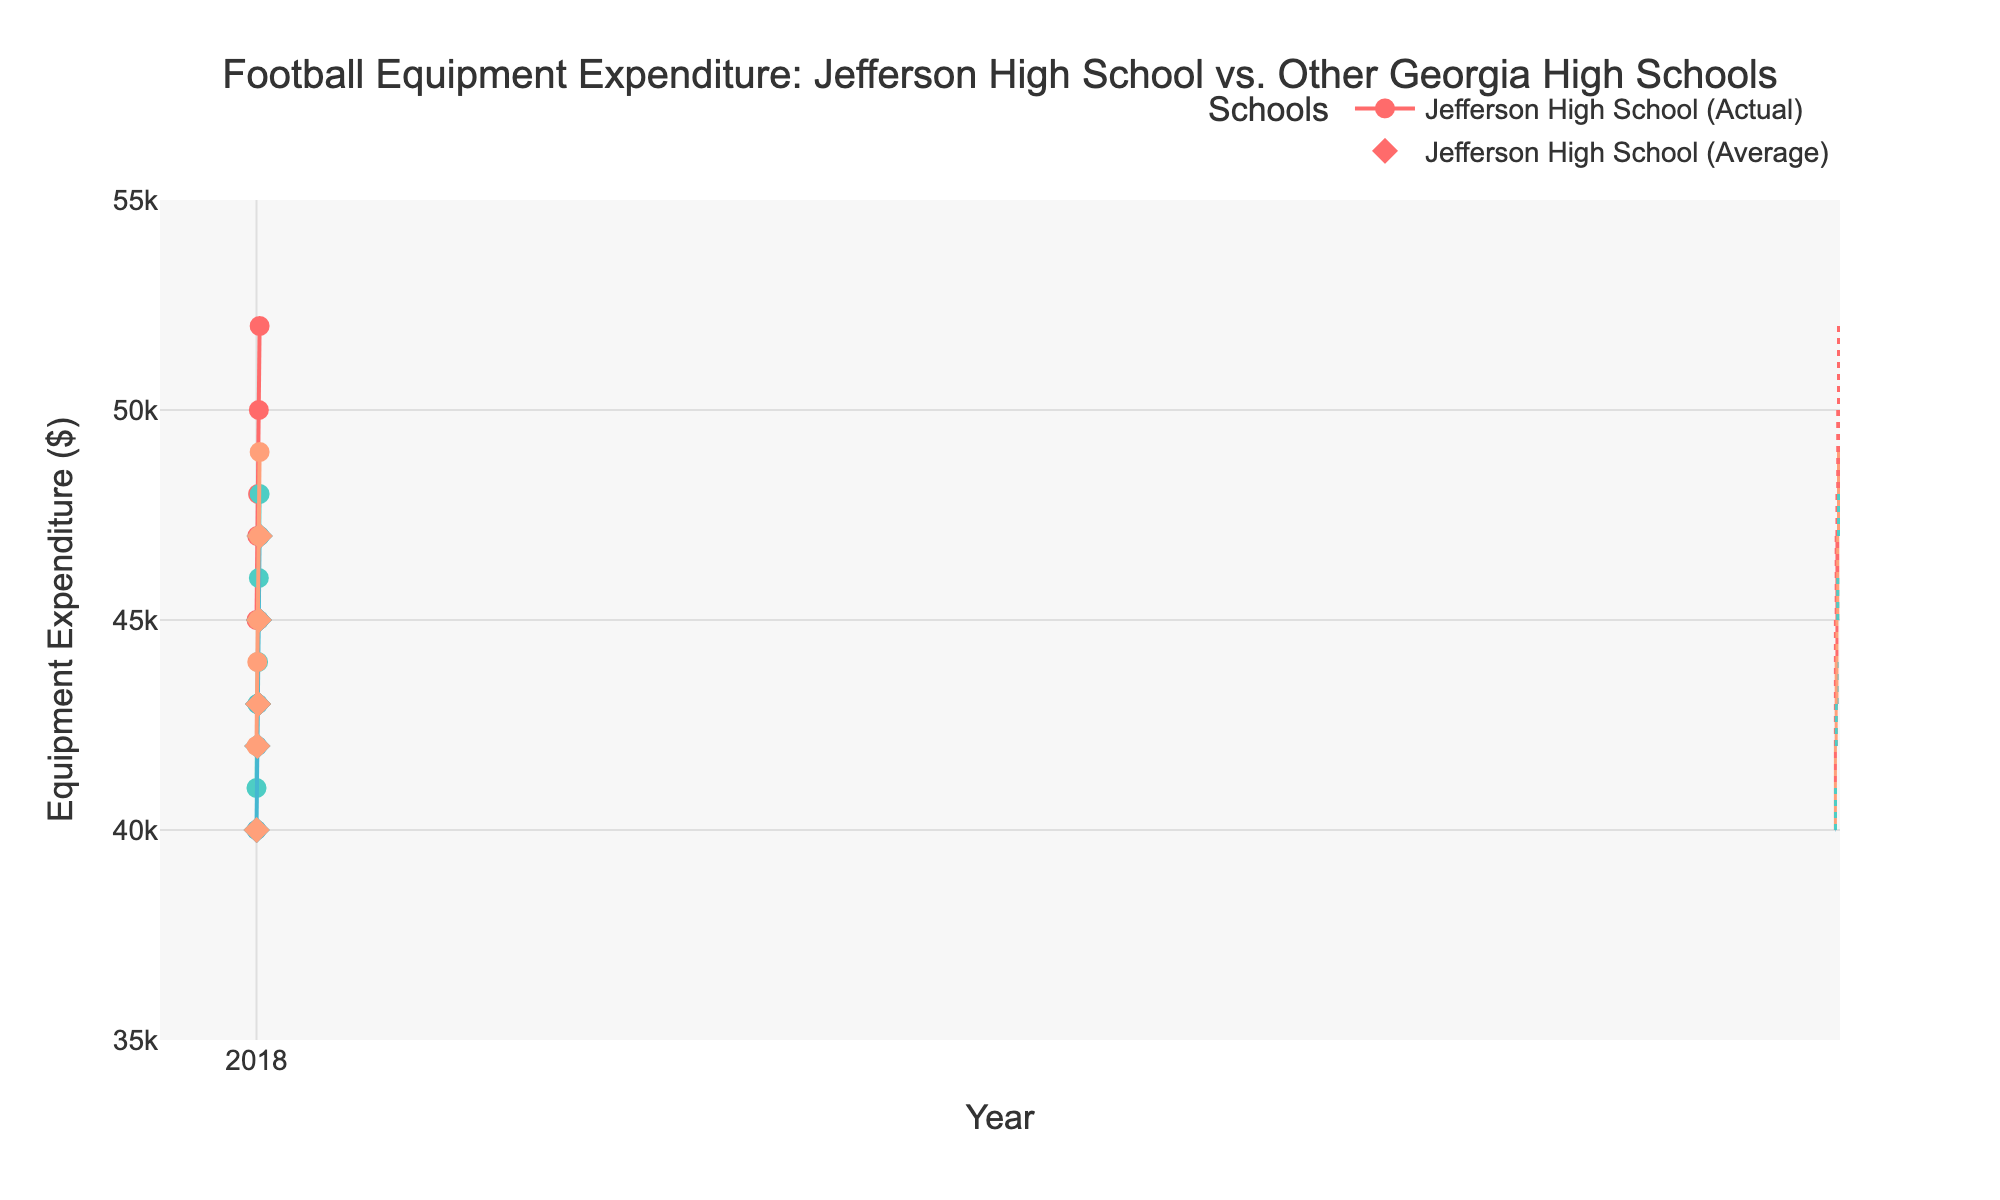what is the title of the plot? The title is located at the top of the plot and reads "Football Equipment Expenditure: Jefferson High School vs. Other Georgia High Schools."
Answer: Football Equipment Expenditure: Jefferson High School vs. Other Georgia High Schools What is the y-axis title? The y-axis title can be found on the side of the chart and reads "Equipment Expenditure ($)."
Answer: Equipment Expenditure ($) How many schools are compared in the plot? The plot compares four different schools, which can be identified by looking at the different lines and markers in the figure corresponding to each school.
Answer: Four What is the color associated with Jefferson High School? Jefferson High School's actual expenditure is marked with a specific color used for the line and circle markers, which is red.
Answer: Red How did Jefferson High School's expenditure trend relative to other schools' average in 2019? By observing the plot for the year 2019, you can see that Jefferson High School's marker is higher than the average indicated by the diamond marker.
Answer: Higher What was the range of Jefferson High School's expenditure from 2018 to 2022? To find the range, identify the highest and lowest expenditures of Jefferson High School from the figure. The highest is $52000 in 2022, and the lowest is $45000 in 2018. The range is $52000 - $45000.
Answer: $7000 How does the trend of Jefferson High School differ from Mill Creek High School over these years? By examining the plot, both schools show an increasing trend in expenditure. However, Jefferson High School's expenditures are consistently higher than those of Mill Creek High School.
Answer: Consistently higher What is the overall trend of football equipment expenditures for Jefferson High School from 2018 to 2022? By tracking Jefferson High School's expenditure line from 2018 to 2022, the overall trend is increasing.
Answer: Increasing What is the maximum difference in equipment expenditure between Jefferson High School and other high schools' average in a single year? To find the maximum difference, observe each year: the differences are $5000 (2018), $5000 (2019), $5000 (2020), $5000 (2021), and $5000 (2022). The max difference is $5000.
Answer: $5000 